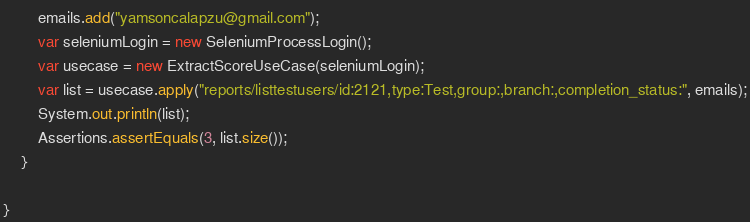Convert code to text. <code><loc_0><loc_0><loc_500><loc_500><_Java_>        emails.add("yamsoncalapzu@gmail.com");
        var seleniumLogin = new SeleniumProcessLogin();
        var usecase = new ExtractScoreUseCase(seleniumLogin);
        var list = usecase.apply("reports/listtestusers/id:2121,type:Test,group:,branch:,completion_status:", emails);
        System.out.println(list);
        Assertions.assertEquals(3, list.size());
    }

}</code> 